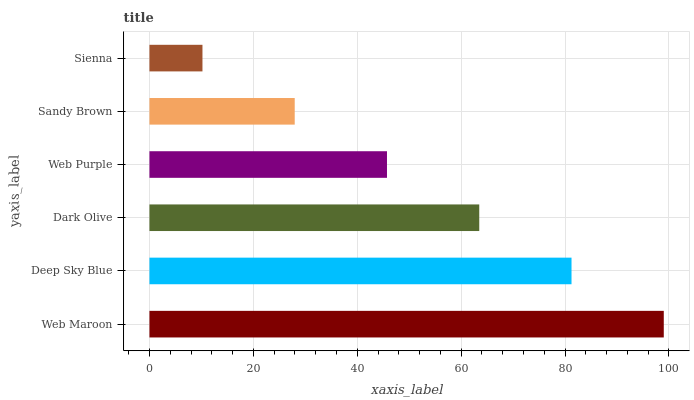Is Sienna the minimum?
Answer yes or no. Yes. Is Web Maroon the maximum?
Answer yes or no. Yes. Is Deep Sky Blue the minimum?
Answer yes or no. No. Is Deep Sky Blue the maximum?
Answer yes or no. No. Is Web Maroon greater than Deep Sky Blue?
Answer yes or no. Yes. Is Deep Sky Blue less than Web Maroon?
Answer yes or no. Yes. Is Deep Sky Blue greater than Web Maroon?
Answer yes or no. No. Is Web Maroon less than Deep Sky Blue?
Answer yes or no. No. Is Dark Olive the high median?
Answer yes or no. Yes. Is Web Purple the low median?
Answer yes or no. Yes. Is Web Purple the high median?
Answer yes or no. No. Is Sienna the low median?
Answer yes or no. No. 